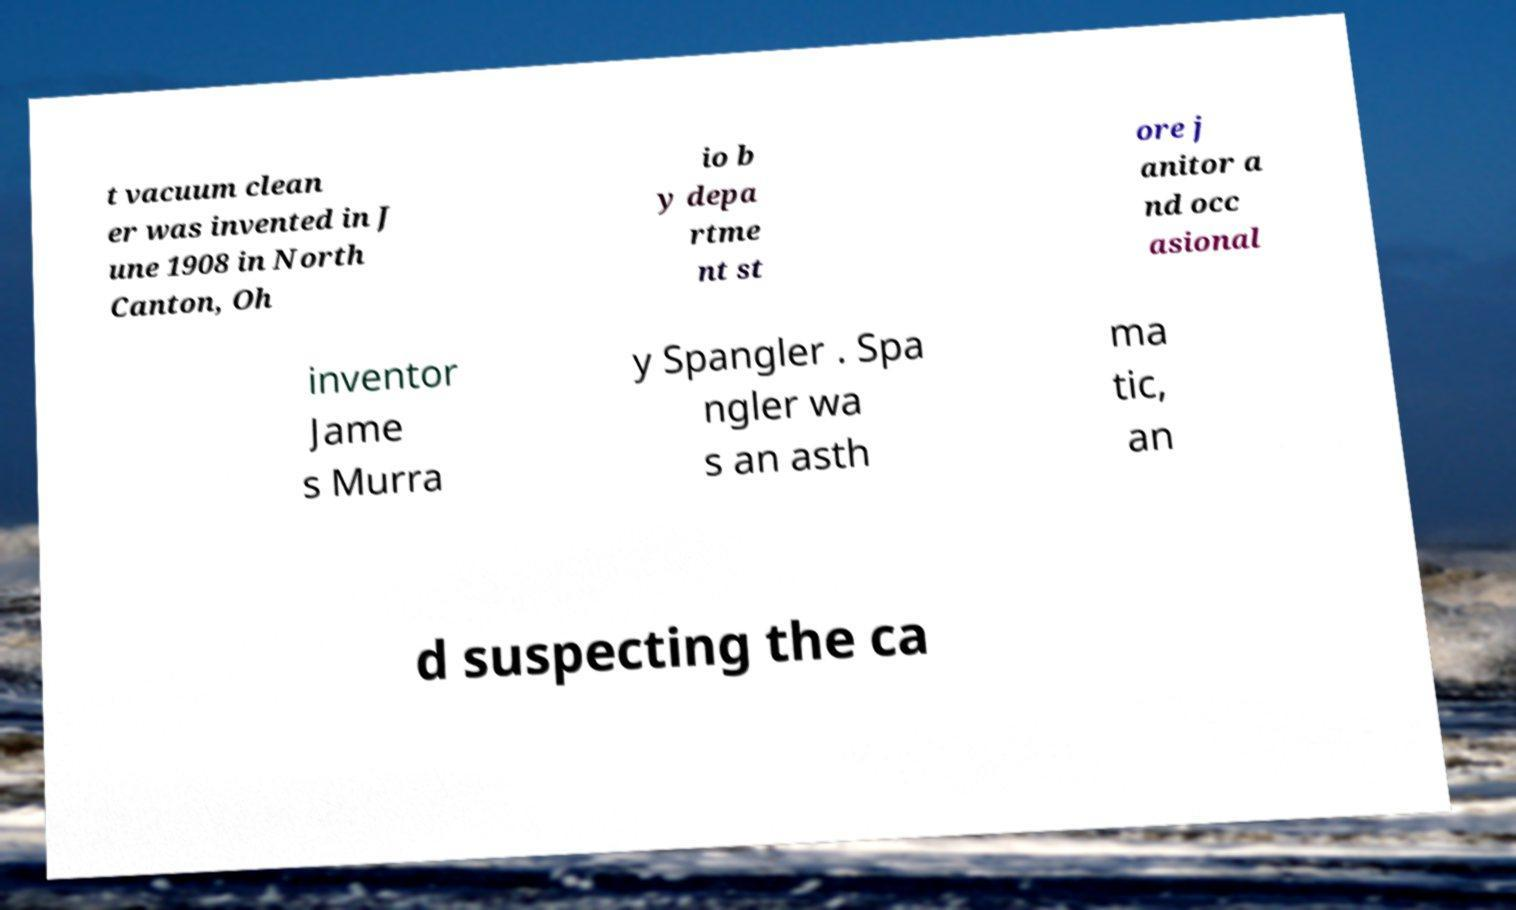Can you accurately transcribe the text from the provided image for me? t vacuum clean er was invented in J une 1908 in North Canton, Oh io b y depa rtme nt st ore j anitor a nd occ asional inventor Jame s Murra y Spangler . Spa ngler wa s an asth ma tic, an d suspecting the ca 